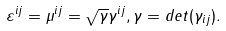Convert formula to latex. <formula><loc_0><loc_0><loc_500><loc_500>\varepsilon ^ { i j } = \mu ^ { i j } = \sqrt { \gamma } \gamma ^ { i j } , \gamma = d e t ( \gamma _ { i j } ) .</formula> 